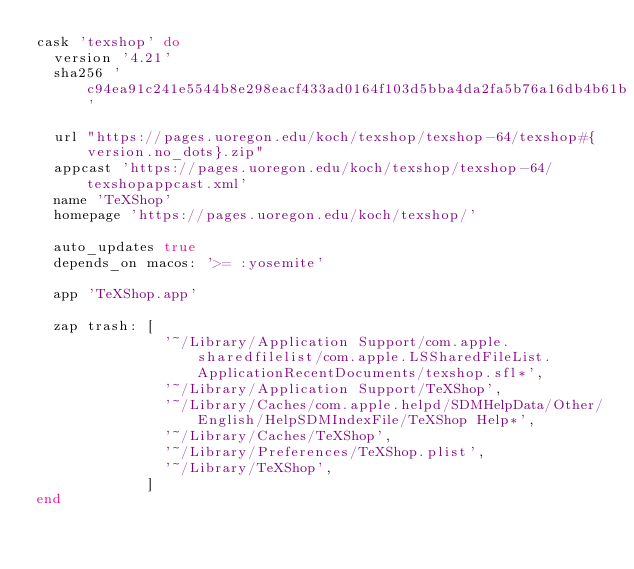<code> <loc_0><loc_0><loc_500><loc_500><_Ruby_>cask 'texshop' do
  version '4.21'
  sha256 'c94ea91c241e5544b8e298eacf433ad0164f103d5bba4da2fa5b76a16db4b61b'

  url "https://pages.uoregon.edu/koch/texshop/texshop-64/texshop#{version.no_dots}.zip"
  appcast 'https://pages.uoregon.edu/koch/texshop/texshop-64/texshopappcast.xml'
  name 'TeXShop'
  homepage 'https://pages.uoregon.edu/koch/texshop/'

  auto_updates true
  depends_on macos: '>= :yosemite'

  app 'TeXShop.app'

  zap trash: [
               '~/Library/Application Support/com.apple.sharedfilelist/com.apple.LSSharedFileList.ApplicationRecentDocuments/texshop.sfl*',
               '~/Library/Application Support/TeXShop',
               '~/Library/Caches/com.apple.helpd/SDMHelpData/Other/English/HelpSDMIndexFile/TeXShop Help*',
               '~/Library/Caches/TeXShop',
               '~/Library/Preferences/TeXShop.plist',
               '~/Library/TeXShop',
             ]
end
</code> 